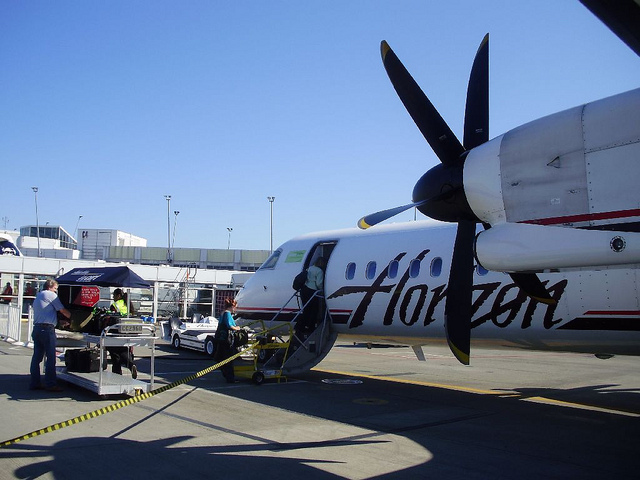<image>What furniture is under the plane? I am not sure what furniture is under the plane. It could be stairs, a ladder, a luggage cart, or there might be none. What furniture is under the plane? There is no furniture under the plane. However, it can be seen stairs, ladder or cart. 